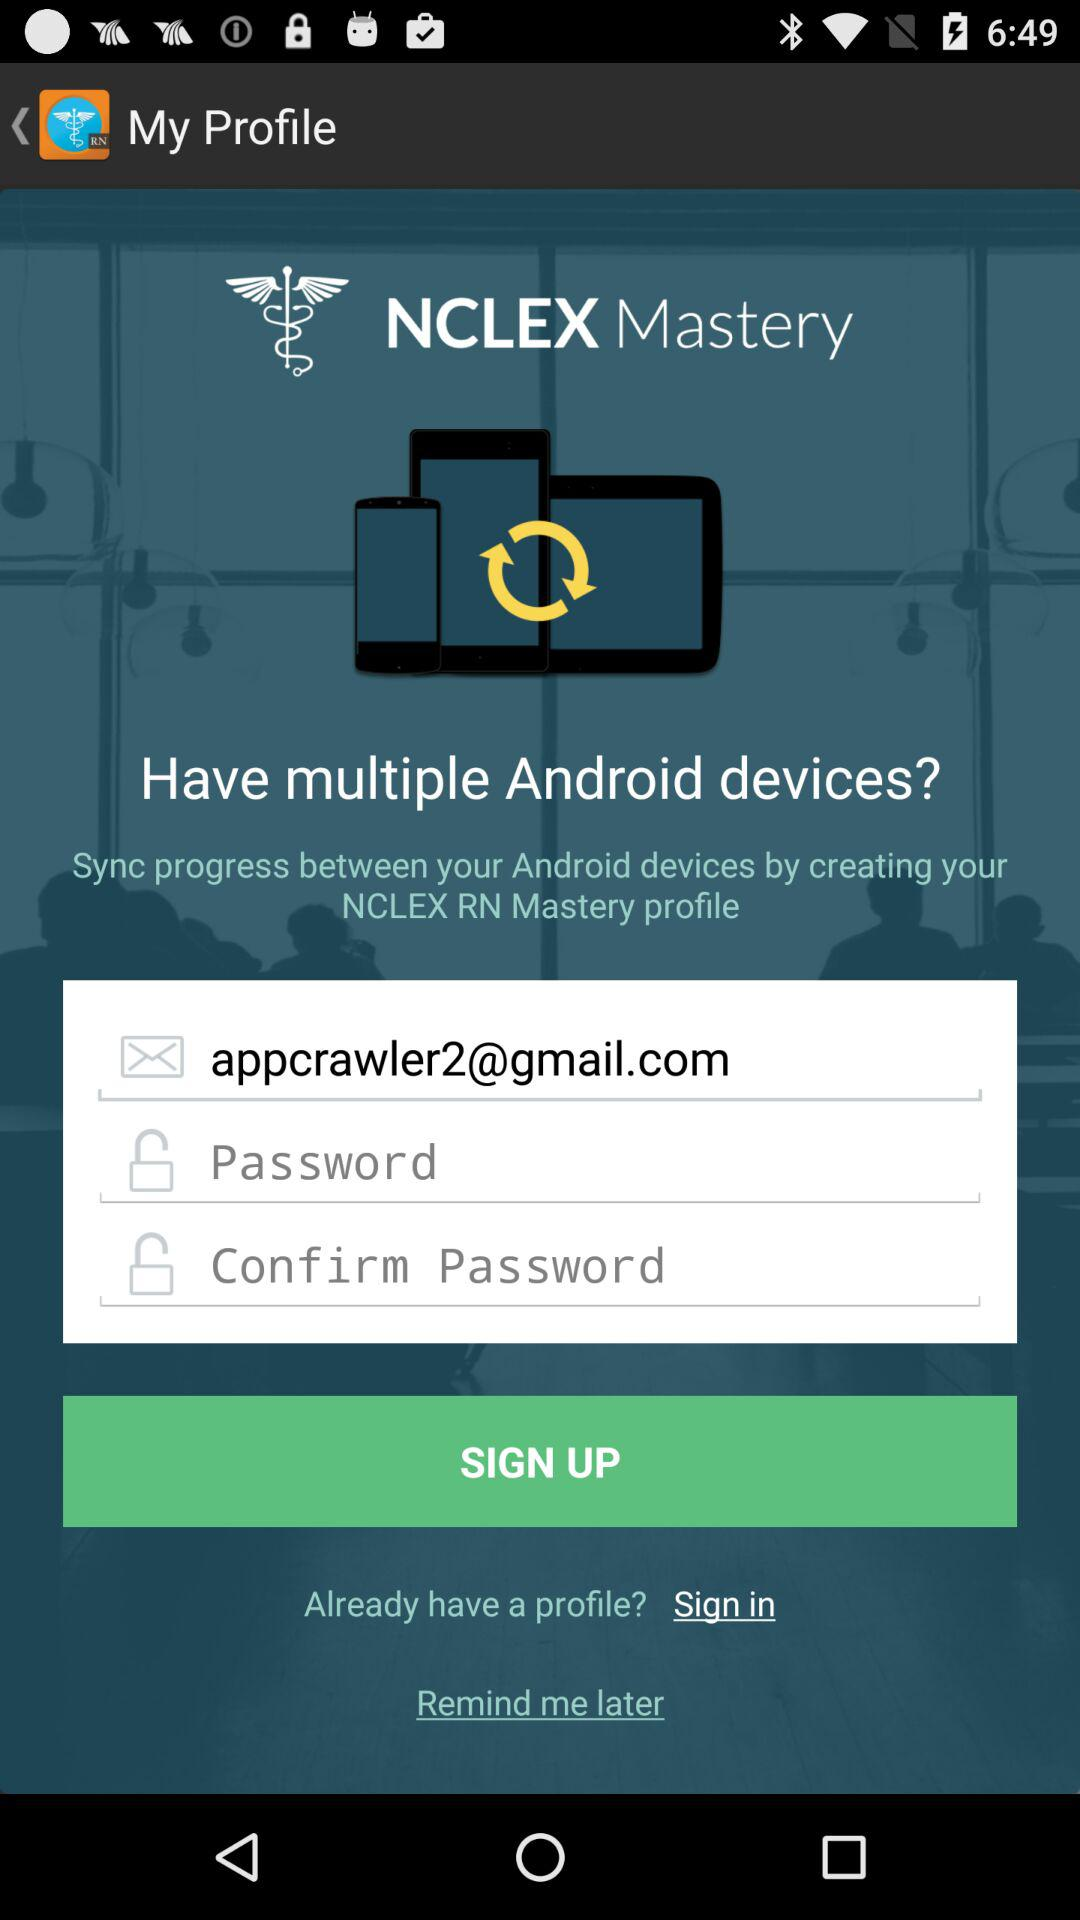What is the email address reflecting on the screen? The email address is appcrawler2@gmail.com. 